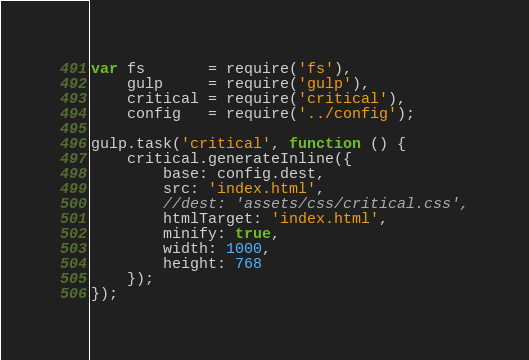Convert code to text. <code><loc_0><loc_0><loc_500><loc_500><_JavaScript_>var fs       = require('fs'),
	gulp     = require('gulp'),
	critical = require('critical'),
	config   = require('../config');

gulp.task('critical', function () {
	critical.generateInline({
		base: config.dest,
		src: 'index.html',
		//dest: 'assets/css/critical.css',
		htmlTarget: 'index.html',
		minify: true,
		width: 1000,
		height: 768
	});
});
</code> 